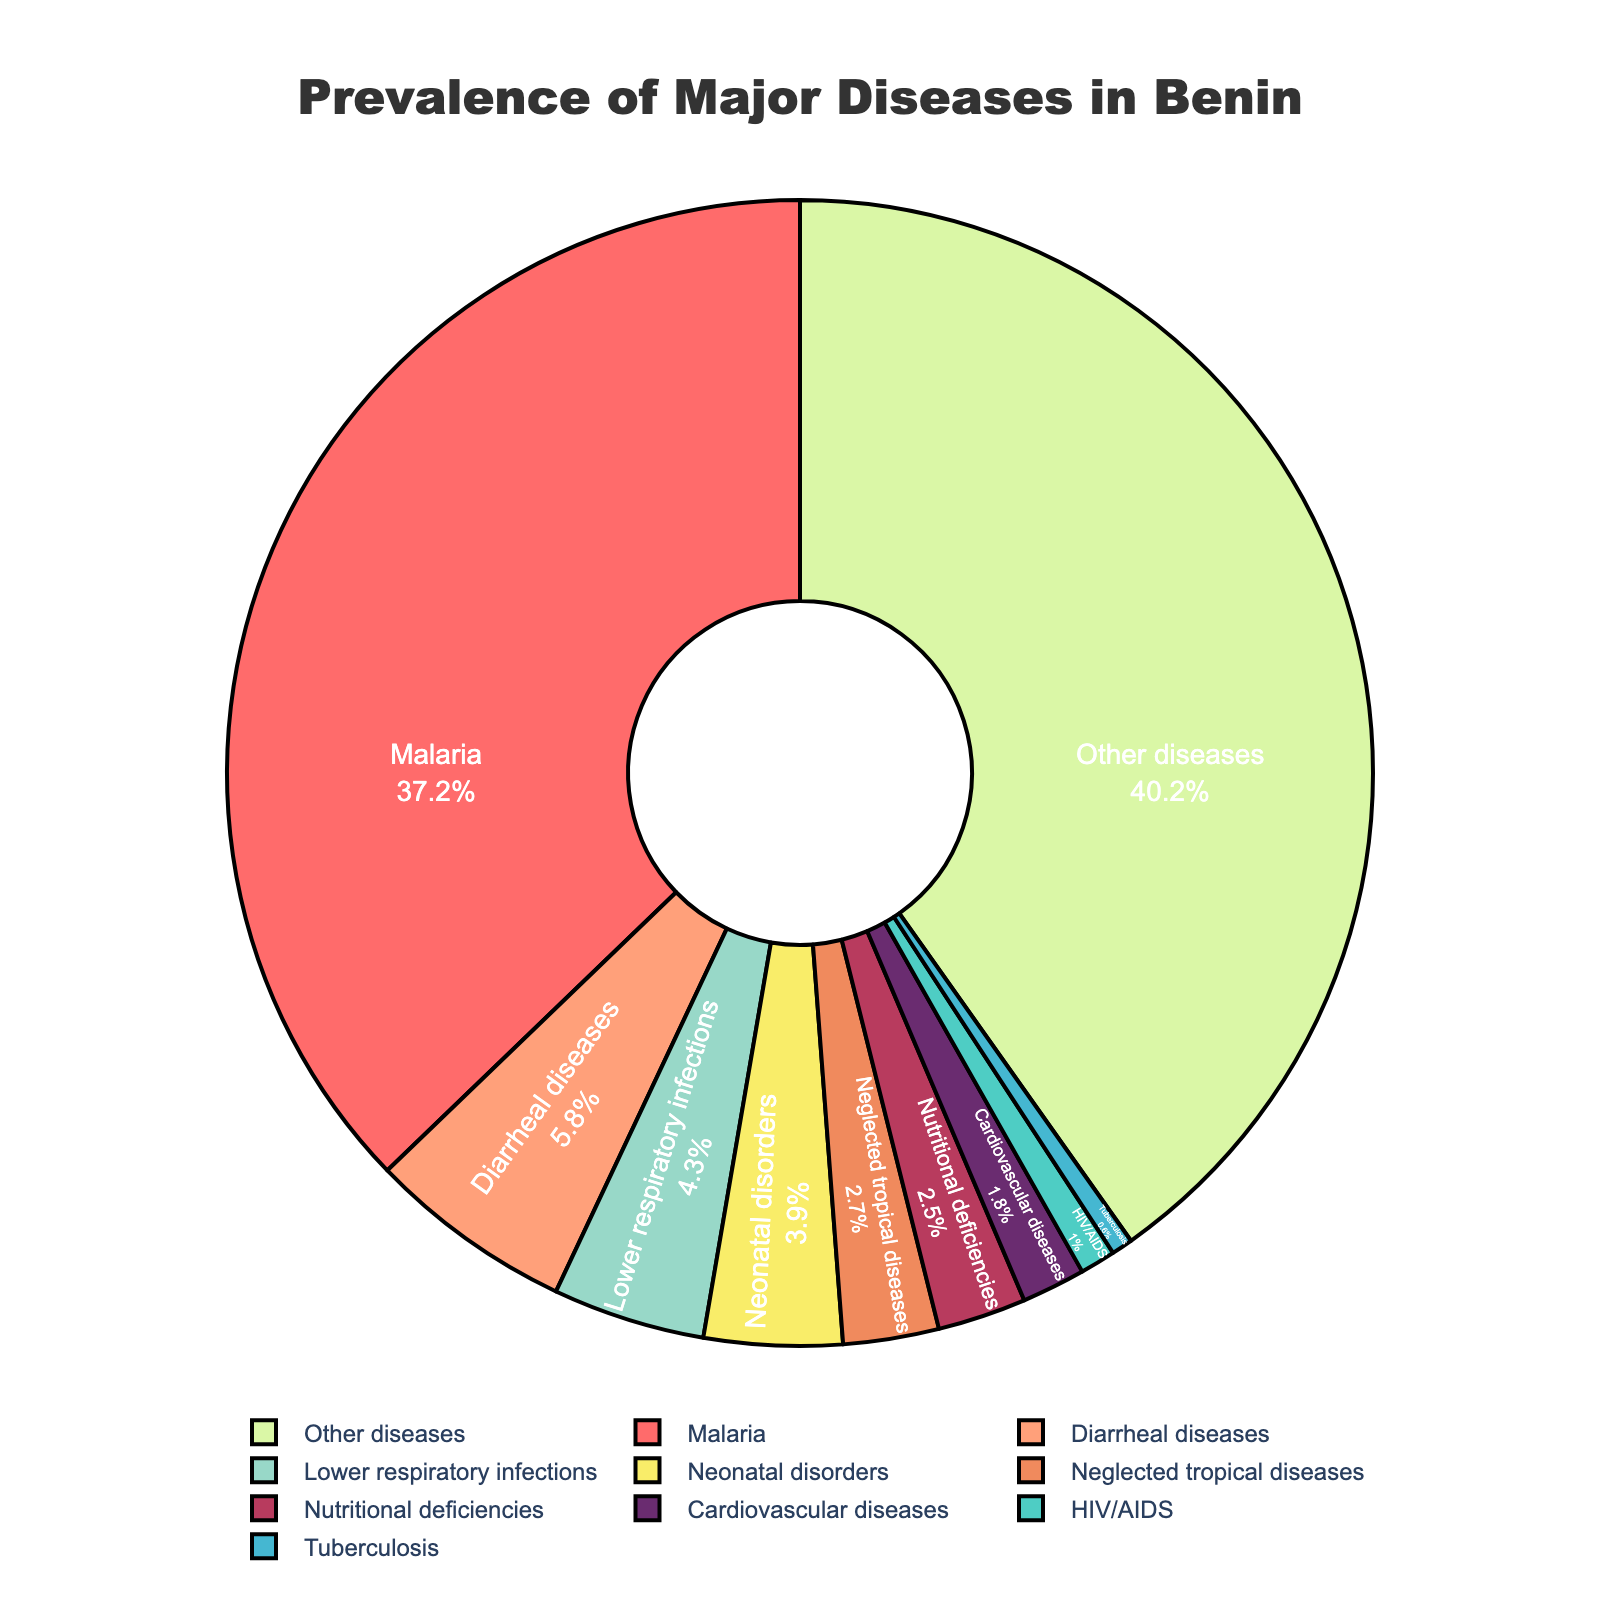What percentage of total diseases does malaria represent? To find the percentage of malaria, we can look at its labeled value in the pie chart. The label for malaria states 37.2%, so malaria represents 37.2% of the total diseases.
Answer: 37.2% Which disease has the second highest prevalence after "Other diseases"? We need to refer to the values labeled in the pie chart. First, identify the label with the highest value, "Other diseases" (40.2%). Then, look for the next highest value which is malaria at 37.2%.
Answer: Malaria What is the combined prevalence of HIV/AIDS, tuberculosis, and neonatal disorders? Add the prevalence values of HIV/AIDS (1.0%), tuberculosis (0.6%), and neonatal disorders (3.9%) together: 1.0 + 0.6 + 3.9 = 5.5%.
Answer: 5.5% How does the prevalence of lower respiratory infections compare to diarrheal diseases? Identify the prevalence of both diseases from the chart: lower respiratory infections (4.3%) and diarrheal diseases (5.8%). Since 4.3 is less than 5.8, the prevalence of lower respiratory infections is lower.
Answer: Lower Which disease has the smallest percentage, and what is its value? From the chart, find the disease with the smallest labeled prevalence value. Tuberculosis at 0.6% is the smallest.
Answer: Tuberculosis, 0.6% What is the prevalence difference between cardiovascular diseases and nutritional deficiencies? Subtract the prevalence of cardiovascular diseases (1.8%) from nutritional deficiencies (2.5%): 2.5 - 1.8 = 0.7%.
Answer: 0.7% If you were to combine the prevalence of all less common diseases (under 2%), what is the total prevalence? Add the prevalence of tuberculosis (0.6%), HIV/AIDS (1.0%), and neglected tropical diseases (2.7%). However, neglected tropical diseases are over 2%, so just sum tuberculosis and HIV/AIDS: 0.6 + 1.0 = 1.6%.
Answer: 1.6% What color is used to represent malnutrition, and why does this color stand out in the chart? The chart uses a distinctive color for malnutrition, noting that it's a bright color for contrast. Nutritional deficiencies are in a light green color (#DAF7A6 in data coding), providing visual standout against other colors.
Answer: Light green 